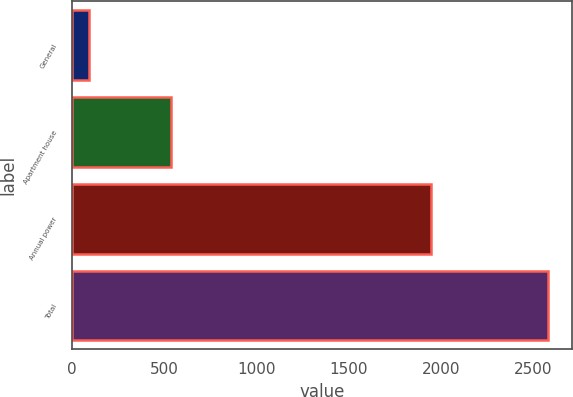<chart> <loc_0><loc_0><loc_500><loc_500><bar_chart><fcel>General<fcel>Apartment house<fcel>Annual power<fcel>Total<nl><fcel>94<fcel>539<fcel>1948<fcel>2581<nl></chart> 